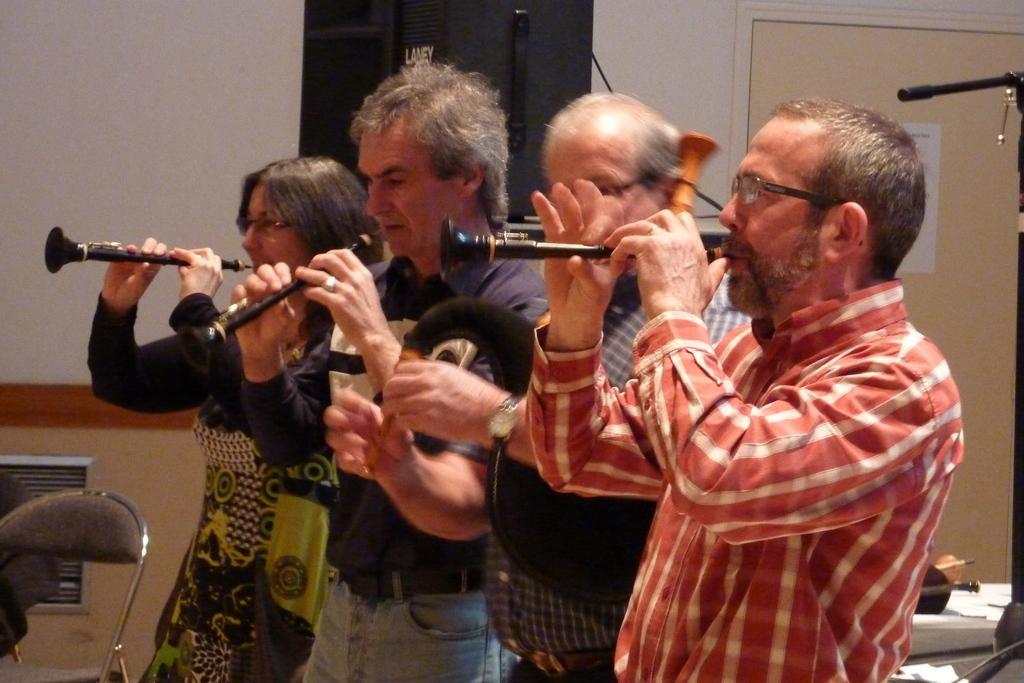How would you summarize this image in a sentence or two? In this image I can see four persons are playing the clarinets. On the right side it looks like a door, on the left side there is the chair. 